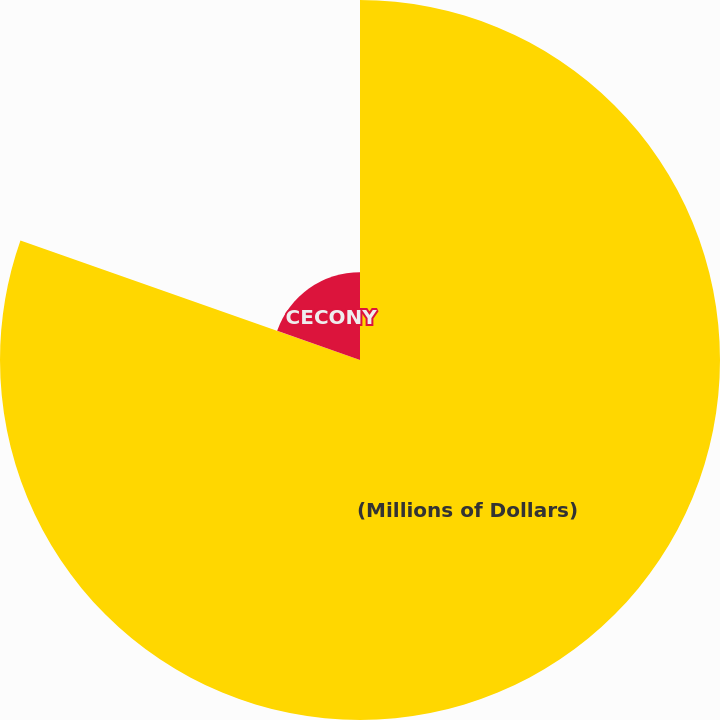Convert chart to OTSL. <chart><loc_0><loc_0><loc_500><loc_500><pie_chart><fcel>(Millions of Dollars)<fcel>CECONY<nl><fcel>80.39%<fcel>19.61%<nl></chart> 